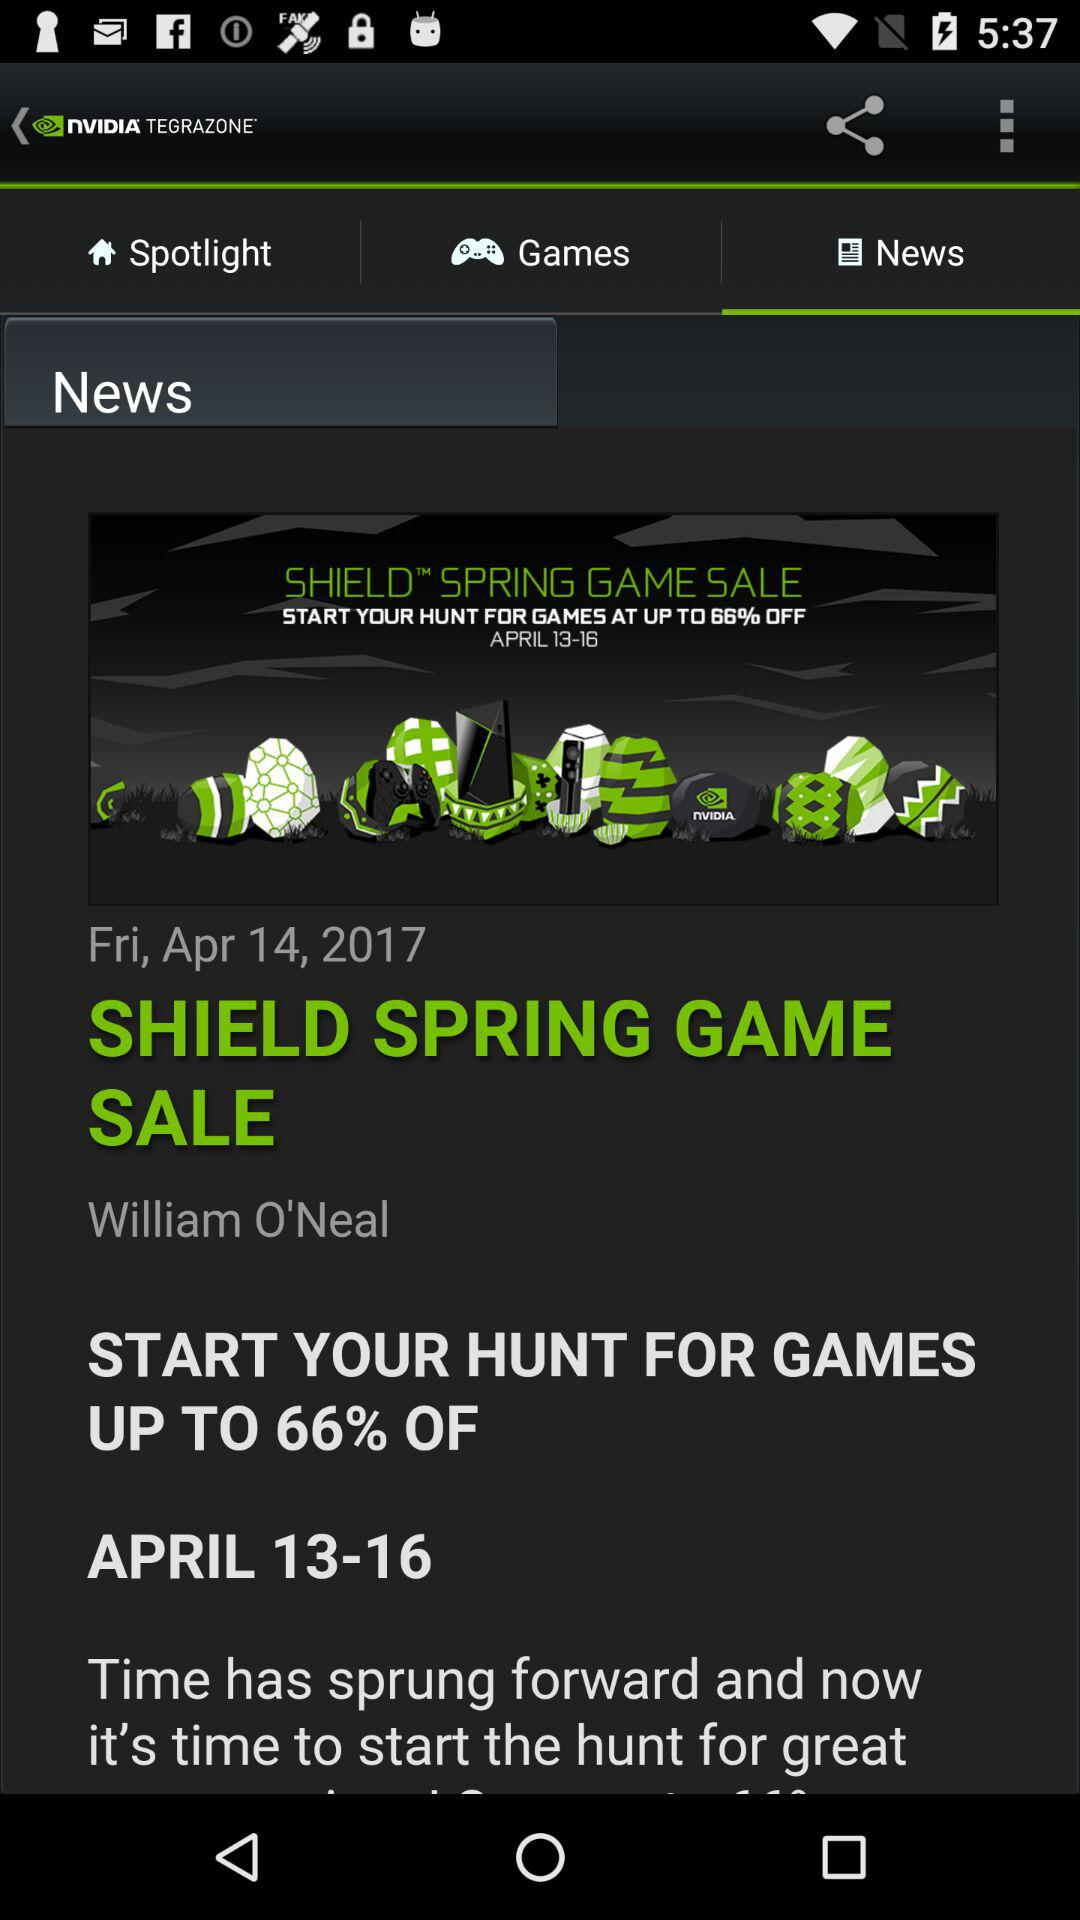What is the name of the person who shared this?
Answer the question using a single word or phrase. William O'Neal 